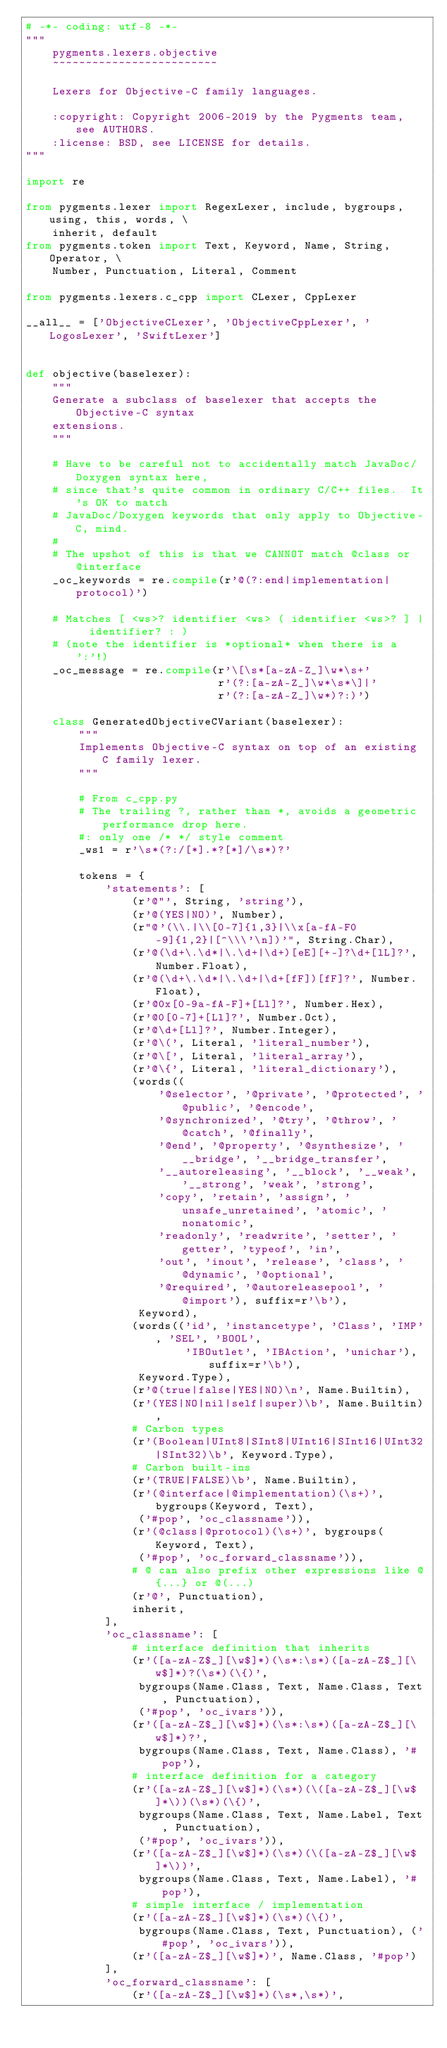<code> <loc_0><loc_0><loc_500><loc_500><_Python_># -*- coding: utf-8 -*-
"""
    pygments.lexers.objective
    ~~~~~~~~~~~~~~~~~~~~~~~~~

    Lexers for Objective-C family languages.

    :copyright: Copyright 2006-2019 by the Pygments team, see AUTHORS.
    :license: BSD, see LICENSE for details.
"""

import re

from pygments.lexer import RegexLexer, include, bygroups, using, this, words, \
    inherit, default
from pygments.token import Text, Keyword, Name, String, Operator, \
    Number, Punctuation, Literal, Comment

from pygments.lexers.c_cpp import CLexer, CppLexer

__all__ = ['ObjectiveCLexer', 'ObjectiveCppLexer', 'LogosLexer', 'SwiftLexer']


def objective(baselexer):
    """
    Generate a subclass of baselexer that accepts the Objective-C syntax
    extensions.
    """

    # Have to be careful not to accidentally match JavaDoc/Doxygen syntax here,
    # since that's quite common in ordinary C/C++ files.  It's OK to match
    # JavaDoc/Doxygen keywords that only apply to Objective-C, mind.
    #
    # The upshot of this is that we CANNOT match @class or @interface
    _oc_keywords = re.compile(r'@(?:end|implementation|protocol)')

    # Matches [ <ws>? identifier <ws> ( identifier <ws>? ] |  identifier? : )
    # (note the identifier is *optional* when there is a ':'!)
    _oc_message = re.compile(r'\[\s*[a-zA-Z_]\w*\s+'
                             r'(?:[a-zA-Z_]\w*\s*\]|'
                             r'(?:[a-zA-Z_]\w*)?:)')

    class GeneratedObjectiveCVariant(baselexer):
        """
        Implements Objective-C syntax on top of an existing C family lexer.
        """

        # From c_cpp.py
        # The trailing ?, rather than *, avoids a geometric performance drop here.
        #: only one /* */ style comment
        _ws1 = r'\s*(?:/[*].*?[*]/\s*)?'

        tokens = {
            'statements': [
                (r'@"', String, 'string'),
                (r'@(YES|NO)', Number),
                (r"@'(\\.|\\[0-7]{1,3}|\\x[a-fA-F0-9]{1,2}|[^\\\'\n])'", String.Char),
                (r'@(\d+\.\d*|\.\d+|\d+)[eE][+-]?\d+[lL]?', Number.Float),
                (r'@(\d+\.\d*|\.\d+|\d+[fF])[fF]?', Number.Float),
                (r'@0x[0-9a-fA-F]+[Ll]?', Number.Hex),
                (r'@0[0-7]+[Ll]?', Number.Oct),
                (r'@\d+[Ll]?', Number.Integer),
                (r'@\(', Literal, 'literal_number'),
                (r'@\[', Literal, 'literal_array'),
                (r'@\{', Literal, 'literal_dictionary'),
                (words((
                    '@selector', '@private', '@protected', '@public', '@encode',
                    '@synchronized', '@try', '@throw', '@catch', '@finally',
                    '@end', '@property', '@synthesize', '__bridge', '__bridge_transfer',
                    '__autoreleasing', '__block', '__weak', '__strong', 'weak', 'strong',
                    'copy', 'retain', 'assign', 'unsafe_unretained', 'atomic', 'nonatomic',
                    'readonly', 'readwrite', 'setter', 'getter', 'typeof', 'in',
                    'out', 'inout', 'release', 'class', '@dynamic', '@optional',
                    '@required', '@autoreleasepool', '@import'), suffix=r'\b'),
                 Keyword),
                (words(('id', 'instancetype', 'Class', 'IMP', 'SEL', 'BOOL',
                        'IBOutlet', 'IBAction', 'unichar'), suffix=r'\b'),
                 Keyword.Type),
                (r'@(true|false|YES|NO)\n', Name.Builtin),
                (r'(YES|NO|nil|self|super)\b', Name.Builtin),
                # Carbon types
                (r'(Boolean|UInt8|SInt8|UInt16|SInt16|UInt32|SInt32)\b', Keyword.Type),
                # Carbon built-ins
                (r'(TRUE|FALSE)\b', Name.Builtin),
                (r'(@interface|@implementation)(\s+)', bygroups(Keyword, Text),
                 ('#pop', 'oc_classname')),
                (r'(@class|@protocol)(\s+)', bygroups(Keyword, Text),
                 ('#pop', 'oc_forward_classname')),
                # @ can also prefix other expressions like @{...} or @(...)
                (r'@', Punctuation),
                inherit,
            ],
            'oc_classname': [
                # interface definition that inherits
                (r'([a-zA-Z$_][\w$]*)(\s*:\s*)([a-zA-Z$_][\w$]*)?(\s*)(\{)',
                 bygroups(Name.Class, Text, Name.Class, Text, Punctuation),
                 ('#pop', 'oc_ivars')),
                (r'([a-zA-Z$_][\w$]*)(\s*:\s*)([a-zA-Z$_][\w$]*)?',
                 bygroups(Name.Class, Text, Name.Class), '#pop'),
                # interface definition for a category
                (r'([a-zA-Z$_][\w$]*)(\s*)(\([a-zA-Z$_][\w$]*\))(\s*)(\{)',
                 bygroups(Name.Class, Text, Name.Label, Text, Punctuation),
                 ('#pop', 'oc_ivars')),
                (r'([a-zA-Z$_][\w$]*)(\s*)(\([a-zA-Z$_][\w$]*\))',
                 bygroups(Name.Class, Text, Name.Label), '#pop'),
                # simple interface / implementation
                (r'([a-zA-Z$_][\w$]*)(\s*)(\{)',
                 bygroups(Name.Class, Text, Punctuation), ('#pop', 'oc_ivars')),
                (r'([a-zA-Z$_][\w$]*)', Name.Class, '#pop')
            ],
            'oc_forward_classname': [
                (r'([a-zA-Z$_][\w$]*)(\s*,\s*)',</code> 